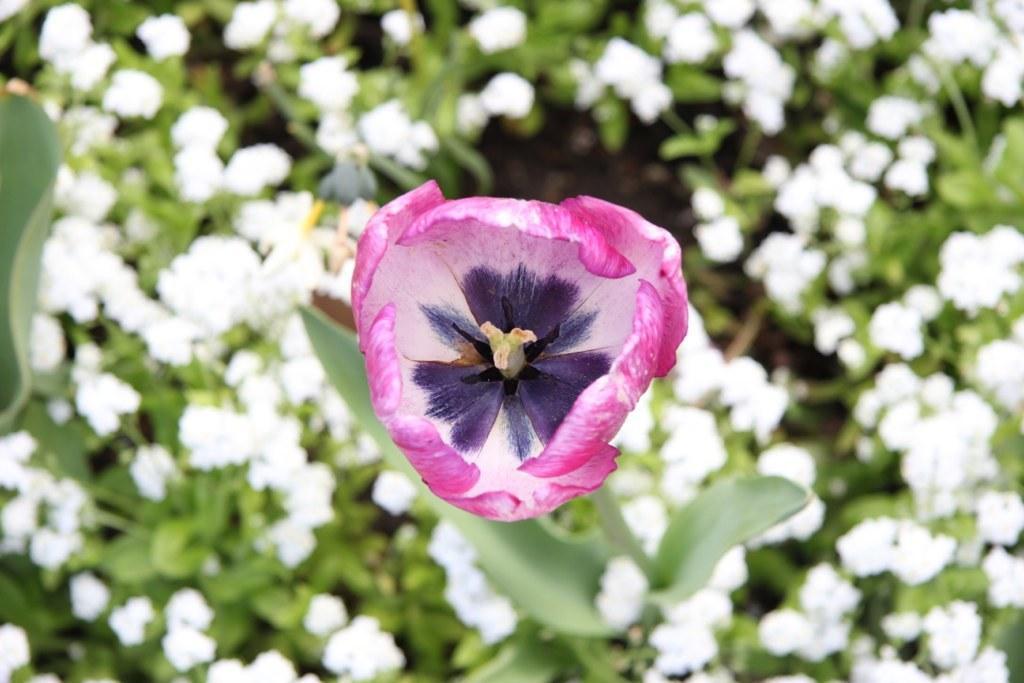Please provide a concise description of this image. In this image, we can see some plants with flowers. We can also see a pink colored flower. We can also see an object on the left. 